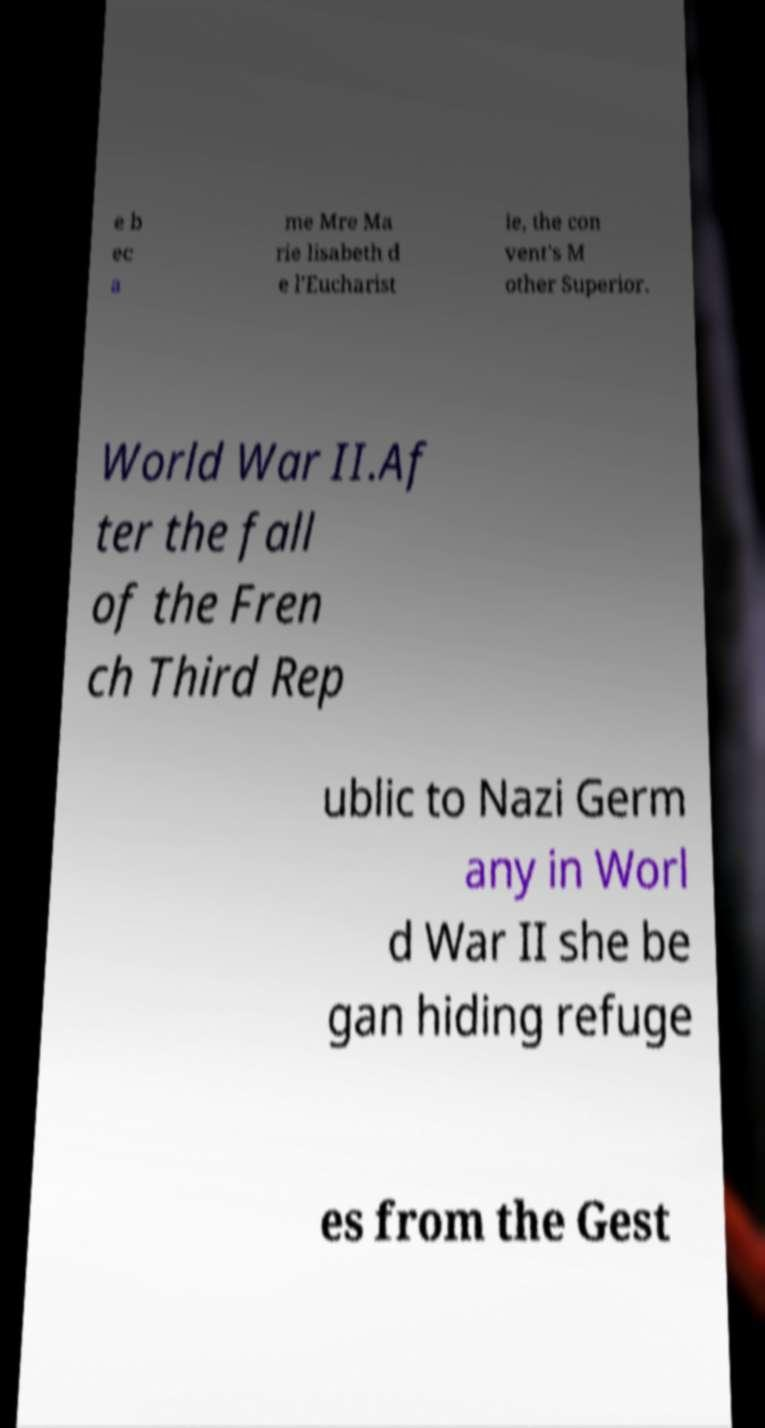Please identify and transcribe the text found in this image. e b ec a me Mre Ma rie lisabeth d e l'Eucharist ie, the con vent's M other Superior. World War II.Af ter the fall of the Fren ch Third Rep ublic to Nazi Germ any in Worl d War II she be gan hiding refuge es from the Gest 